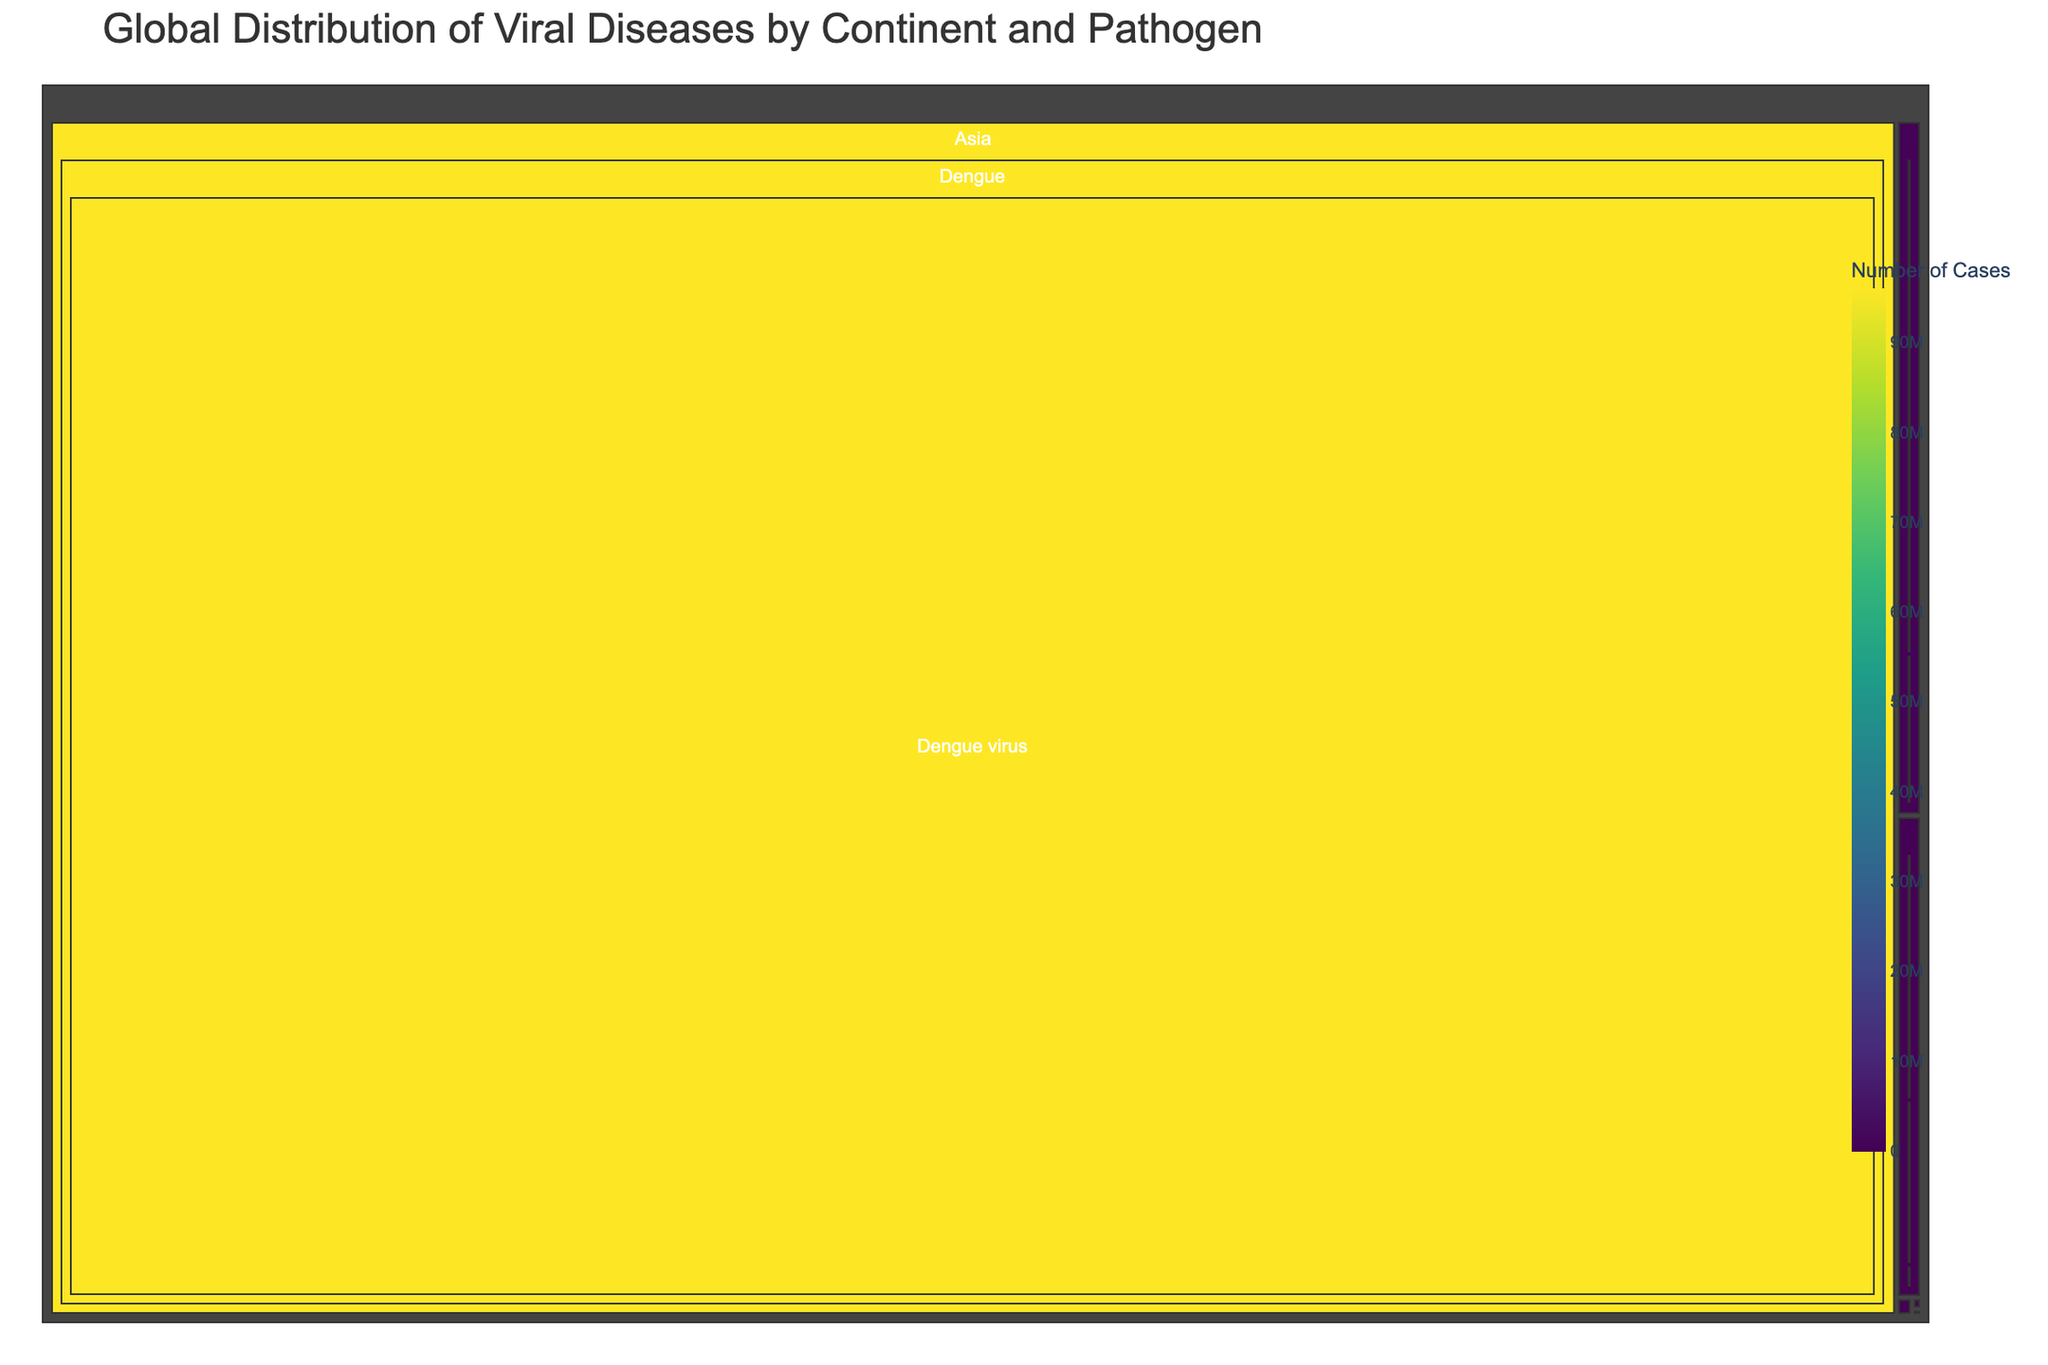Which continent has the highest number of cases for viral diseases? By examining the sizes of the areas representing each continent, Asia has the largest area, indicating the highest number of cases.
Answer: Asia Which disease has the most cases in Africa? Among the areas in Africa, Lassa fever has the largest area representing cases, indicating it has the most cases.
Answer: Lassa fever How many cases of Japanese encephalitis are there in Oceania? Look for the Japanese encephalitis section within the Oceania branch. The corresponding number of cases is provided: 9.
Answer: 9 Which continent has the fewest cases for viral diseases? By comparing the smallest areas for each continent, Oceania has the smallest total area, indicating it has the fewest cases.
Answer: Oceania How do the cases of West Nile fever in North America compare to those in Europe? Compare the sizes of the sections for West Nile fever in North America and Europe. North America's section is larger, indicating more cases.
Answer: More cases in North America What is the combined number of cases for Yellow fever in Africa and South America? Sum the cases of Yellow fever in Africa (200,000) and South America (2,155). 200,000 + 2,155 = 202,155.
Answer: 202,155 List the continents with cases of Japanese encephalitis. Look for branches within the tree that represent Japanese encephalitis and identify their parent continents: Asia and Oceania.
Answer: Asia and Oceania Which pathogen is associated with the most cases in Asia? Look for the largest section under the Asia branch, indicating Dengue, caused by the Dengue virus.
Answer: Dengue virus What is the average number of cases across all diseases in Europe? Sum the cases for all diseases in Europe (10,000 + 1,875 + 200 = 12,075) and divide by the number of diseases (3). 12,075 / 3 ≈ 4,025.
Answer: 4,025 How many data points (diseases) are visualized for North America? Count the number of sections under the North America branch: West Nile fever, St. Louis encephalitis, and Eastern equine encephalitis, resulting in 3.
Answer: 3 